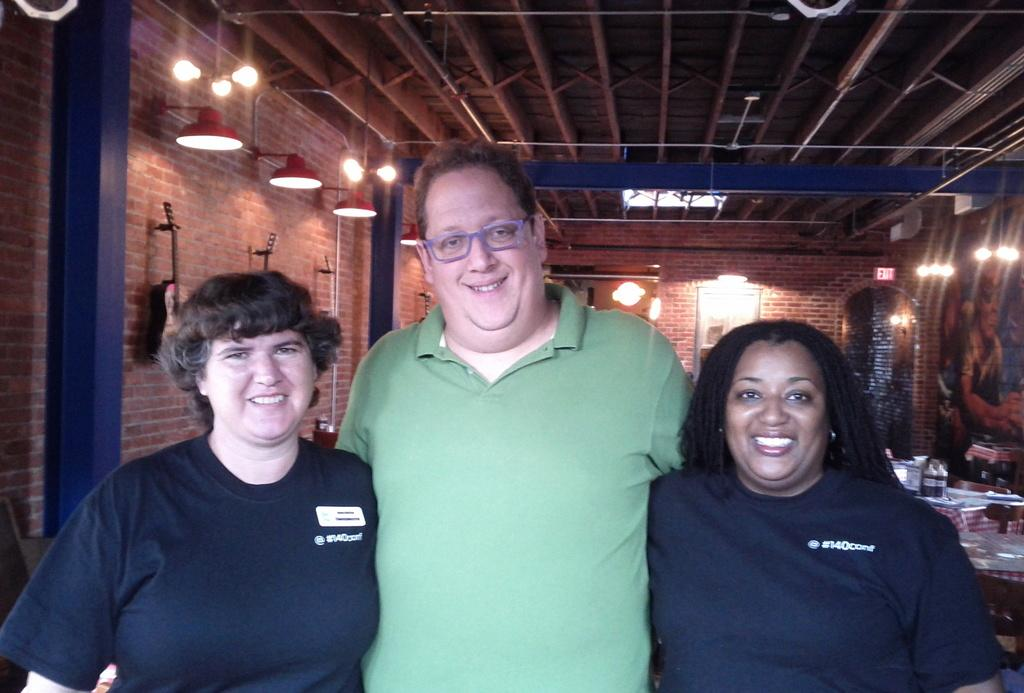How many people are in the image? There are three people in the image. What is the facial expression of the people in the image? The people are smiling. What can be seen in the background of the image? There is a wall, pillars, a guitar, lights, tables, bottles, a roof, and some objects in the background of the image. What type of meat is being cooked on the guitar in the image? There is no meat or cooking activity present in the image; the guitar is an instrument and not a cooking appliance. 